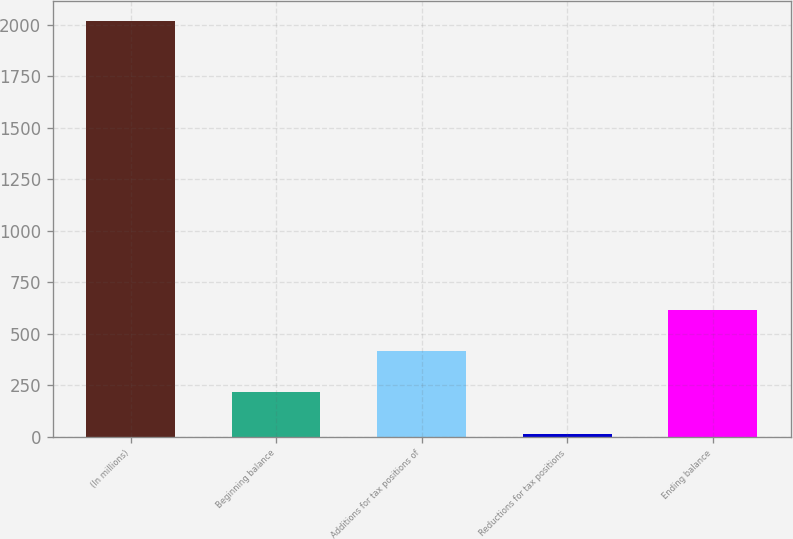<chart> <loc_0><loc_0><loc_500><loc_500><bar_chart><fcel>(In millions)<fcel>Beginning balance<fcel>Additions for tax positions of<fcel>Reductions for tax positions<fcel>Ending balance<nl><fcel>2018<fcel>215.3<fcel>415.6<fcel>15<fcel>615.9<nl></chart> 